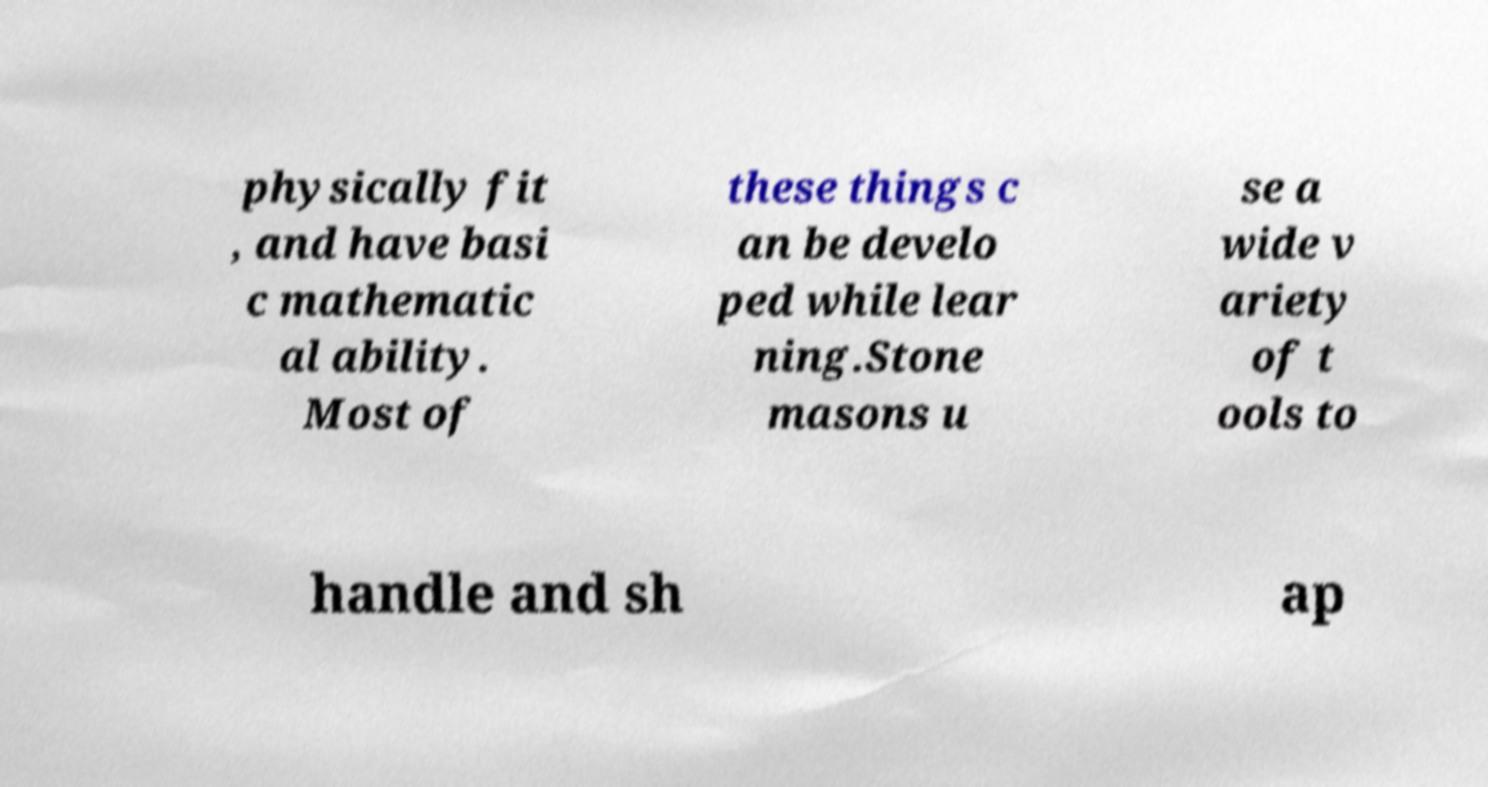Could you assist in decoding the text presented in this image and type it out clearly? physically fit , and have basi c mathematic al ability. Most of these things c an be develo ped while lear ning.Stone masons u se a wide v ariety of t ools to handle and sh ap 